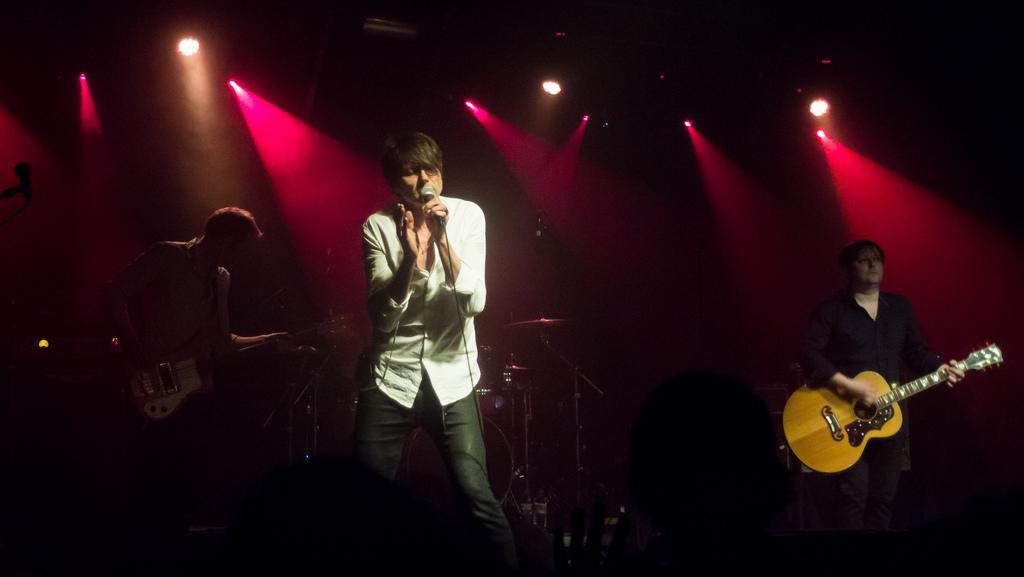What can be seen in the image? There are people in the image. What are some of the people doing in the image? Some of the people are holding guitars, and one person is holding a microphone. What type of snail can be seen participating in the activity in the image? There are no snails present in the image, and the activity cannot be determined from the provided facts. 